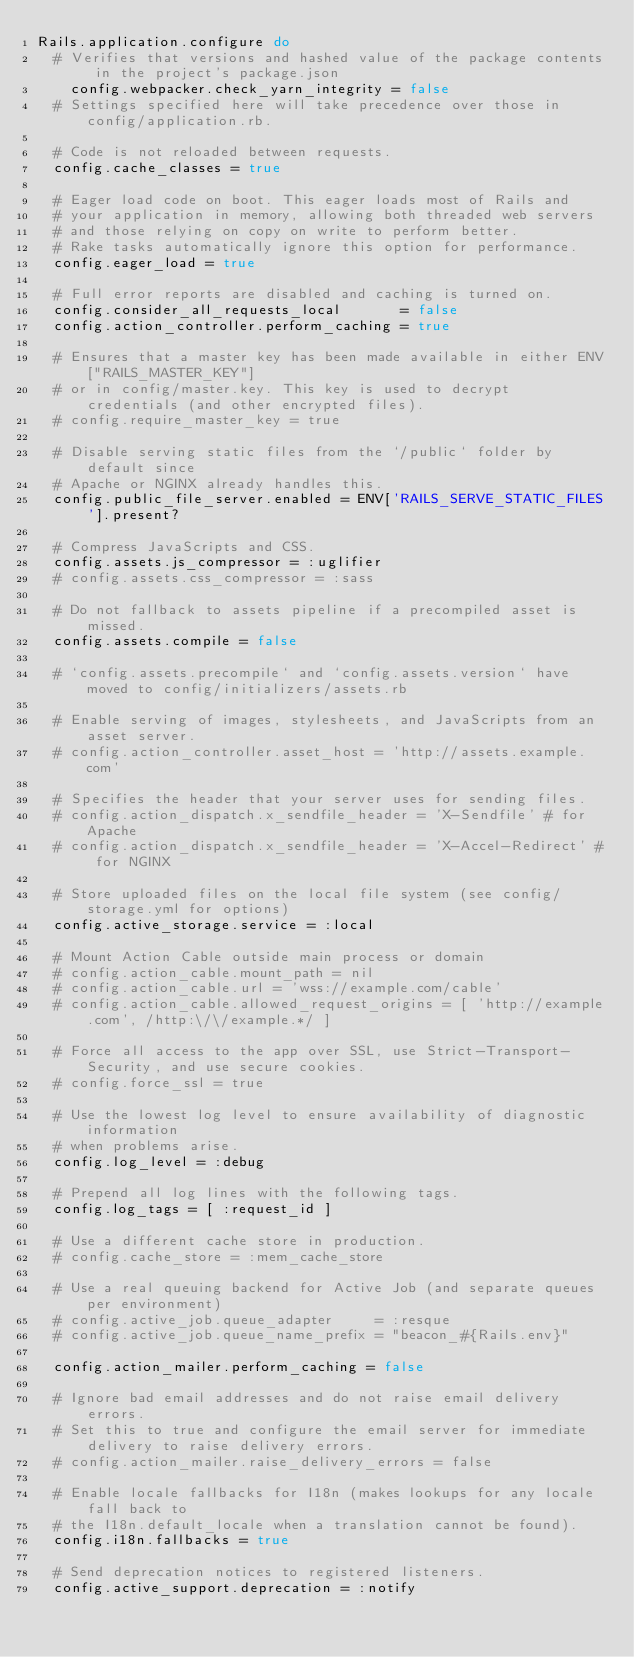Convert code to text. <code><loc_0><loc_0><loc_500><loc_500><_Ruby_>Rails.application.configure do
  # Verifies that versions and hashed value of the package contents in the project's package.json
    config.webpacker.check_yarn_integrity = false
  # Settings specified here will take precedence over those in config/application.rb.

  # Code is not reloaded between requests.
  config.cache_classes = true

  # Eager load code on boot. This eager loads most of Rails and
  # your application in memory, allowing both threaded web servers
  # and those relying on copy on write to perform better.
  # Rake tasks automatically ignore this option for performance.
  config.eager_load = true

  # Full error reports are disabled and caching is turned on.
  config.consider_all_requests_local       = false
  config.action_controller.perform_caching = true

  # Ensures that a master key has been made available in either ENV["RAILS_MASTER_KEY"]
  # or in config/master.key. This key is used to decrypt credentials (and other encrypted files).
  # config.require_master_key = true

  # Disable serving static files from the `/public` folder by default since
  # Apache or NGINX already handles this.
  config.public_file_server.enabled = ENV['RAILS_SERVE_STATIC_FILES'].present?

  # Compress JavaScripts and CSS.
  config.assets.js_compressor = :uglifier
  # config.assets.css_compressor = :sass

  # Do not fallback to assets pipeline if a precompiled asset is missed.
  config.assets.compile = false

  # `config.assets.precompile` and `config.assets.version` have moved to config/initializers/assets.rb

  # Enable serving of images, stylesheets, and JavaScripts from an asset server.
  # config.action_controller.asset_host = 'http://assets.example.com'

  # Specifies the header that your server uses for sending files.
  # config.action_dispatch.x_sendfile_header = 'X-Sendfile' # for Apache
  # config.action_dispatch.x_sendfile_header = 'X-Accel-Redirect' # for NGINX

  # Store uploaded files on the local file system (see config/storage.yml for options)
  config.active_storage.service = :local

  # Mount Action Cable outside main process or domain
  # config.action_cable.mount_path = nil
  # config.action_cable.url = 'wss://example.com/cable'
  # config.action_cable.allowed_request_origins = [ 'http://example.com', /http:\/\/example.*/ ]

  # Force all access to the app over SSL, use Strict-Transport-Security, and use secure cookies.
  # config.force_ssl = true

  # Use the lowest log level to ensure availability of diagnostic information
  # when problems arise.
  config.log_level = :debug

  # Prepend all log lines with the following tags.
  config.log_tags = [ :request_id ]

  # Use a different cache store in production.
  # config.cache_store = :mem_cache_store

  # Use a real queuing backend for Active Job (and separate queues per environment)
  # config.active_job.queue_adapter     = :resque
  # config.active_job.queue_name_prefix = "beacon_#{Rails.env}"

  config.action_mailer.perform_caching = false

  # Ignore bad email addresses and do not raise email delivery errors.
  # Set this to true and configure the email server for immediate delivery to raise delivery errors.
  # config.action_mailer.raise_delivery_errors = false

  # Enable locale fallbacks for I18n (makes lookups for any locale fall back to
  # the I18n.default_locale when a translation cannot be found).
  config.i18n.fallbacks = true

  # Send deprecation notices to registered listeners.
  config.active_support.deprecation = :notify
</code> 